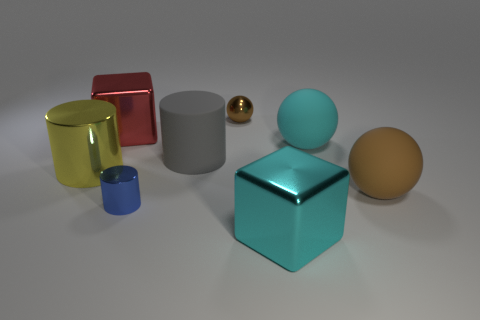Subtract all small metal spheres. How many spheres are left? 2 Add 1 brown rubber blocks. How many objects exist? 9 Subtract 1 cubes. How many cubes are left? 1 Subtract all cubes. How many objects are left? 6 Subtract all brown balls. How many balls are left? 1 Subtract 0 red cylinders. How many objects are left? 8 Subtract all blue cubes. Subtract all purple spheres. How many cubes are left? 2 Subtract all brown balls. How many yellow cylinders are left? 1 Subtract all small blue things. Subtract all tiny brown metallic things. How many objects are left? 6 Add 8 cyan matte objects. How many cyan matte objects are left? 9 